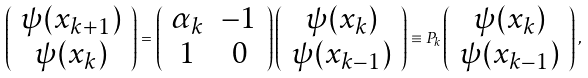Convert formula to latex. <formula><loc_0><loc_0><loc_500><loc_500>\left ( \begin{array} { c } \psi ( x _ { k + 1 } ) \\ \psi ( x _ { k } ) \end{array} \right ) = \left ( \begin{array} { c c } \alpha _ { k } & - 1 \\ 1 & 0 \end{array} \right ) \left ( \begin{array} { c } \psi ( x _ { k } ) \\ \psi ( x _ { k - 1 } ) \end{array} \right ) \equiv P _ { k } \left ( \begin{array} { c } \psi ( x _ { k } ) \\ \psi ( x _ { k - 1 } ) \end{array} \right ) ,</formula> 